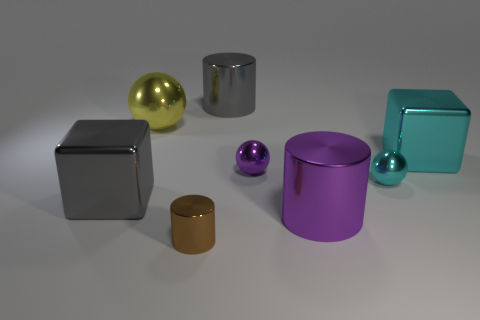There is a purple shiny thing that is left of the big purple metallic thing; what is its size?
Offer a terse response. Small. Does the big sphere have the same color as the block that is left of the tiny brown metal object?
Provide a short and direct response. No. Are there any tiny blocks that have the same color as the small metallic cylinder?
Offer a very short reply. No. Are the small brown thing and the cube to the left of the brown metallic thing made of the same material?
Offer a terse response. Yes. How many small things are either blocks or red cylinders?
Your answer should be compact. 0. Are there fewer big cyan metallic cubes than metal things?
Ensure brevity in your answer.  Yes. There is a gray thing to the left of the big sphere; is its size the same as the metallic cube behind the purple sphere?
Your answer should be compact. Yes. What number of cyan things are either metallic objects or rubber spheres?
Make the answer very short. 2. Are there more gray cubes than tiny matte cubes?
Offer a terse response. Yes. Does the big metal ball have the same color as the small cylinder?
Your answer should be very brief. No. 